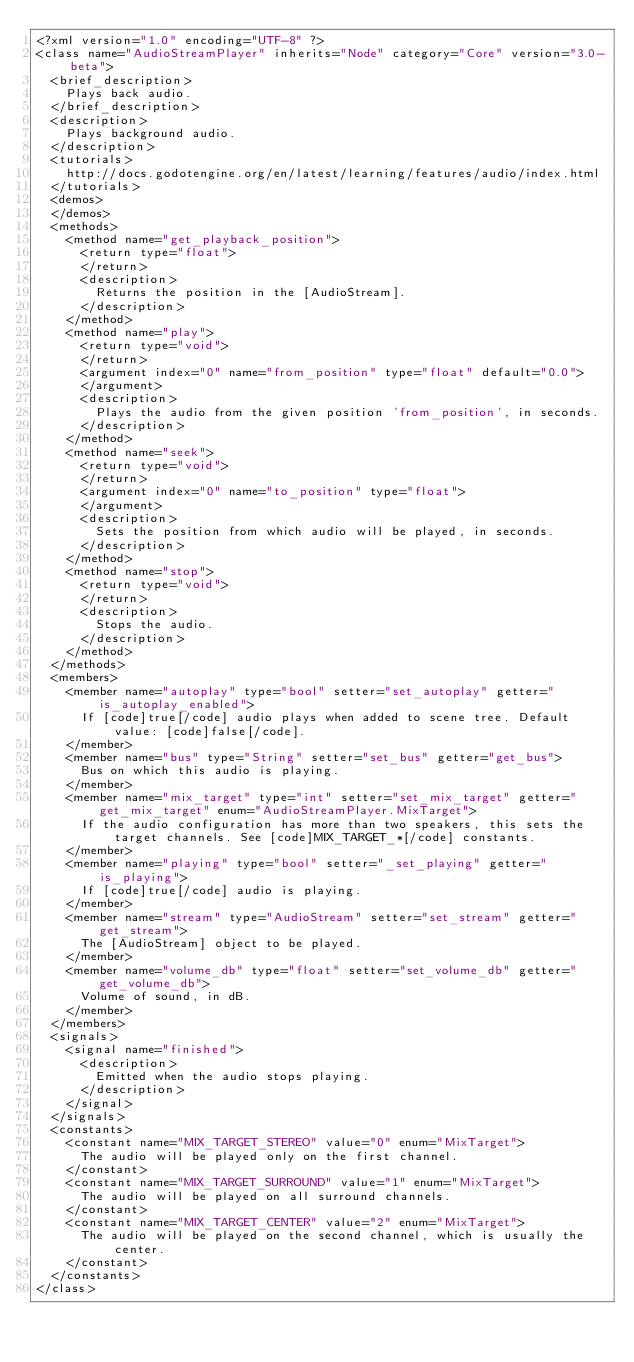Convert code to text. <code><loc_0><loc_0><loc_500><loc_500><_XML_><?xml version="1.0" encoding="UTF-8" ?>
<class name="AudioStreamPlayer" inherits="Node" category="Core" version="3.0-beta">
	<brief_description>
		Plays back audio.
	</brief_description>
	<description>
		Plays background audio.
	</description>
	<tutorials>
		http://docs.godotengine.org/en/latest/learning/features/audio/index.html
	</tutorials>
	<demos>
	</demos>
	<methods>
		<method name="get_playback_position">
			<return type="float">
			</return>
			<description>
				Returns the position in the [AudioStream].
			</description>
		</method>
		<method name="play">
			<return type="void">
			</return>
			<argument index="0" name="from_position" type="float" default="0.0">
			</argument>
			<description>
				Plays the audio from the given position 'from_position', in seconds.
			</description>
		</method>
		<method name="seek">
			<return type="void">
			</return>
			<argument index="0" name="to_position" type="float">
			</argument>
			<description>
				Sets the position from which audio will be played, in seconds.
			</description>
		</method>
		<method name="stop">
			<return type="void">
			</return>
			<description>
				Stops the audio.
			</description>
		</method>
	</methods>
	<members>
		<member name="autoplay" type="bool" setter="set_autoplay" getter="is_autoplay_enabled">
			If [code]true[/code] audio plays when added to scene tree. Default value: [code]false[/code].
		</member>
		<member name="bus" type="String" setter="set_bus" getter="get_bus">
			Bus on which this audio is playing.
		</member>
		<member name="mix_target" type="int" setter="set_mix_target" getter="get_mix_target" enum="AudioStreamPlayer.MixTarget">
			If the audio configuration has more than two speakers, this sets the target channels. See [code]MIX_TARGET_*[/code] constants.
		</member>
		<member name="playing" type="bool" setter="_set_playing" getter="is_playing">
			If [code]true[/code] audio is playing.
		</member>
		<member name="stream" type="AudioStream" setter="set_stream" getter="get_stream">
			The [AudioStream] object to be played.
		</member>
		<member name="volume_db" type="float" setter="set_volume_db" getter="get_volume_db">
			Volume of sound, in dB.
		</member>
	</members>
	<signals>
		<signal name="finished">
			<description>
				Emitted when the audio stops playing.
			</description>
		</signal>
	</signals>
	<constants>
		<constant name="MIX_TARGET_STEREO" value="0" enum="MixTarget">
			The audio will be played only on the first channel.
		</constant>
		<constant name="MIX_TARGET_SURROUND" value="1" enum="MixTarget">
			The audio will be played on all surround channels.
		</constant>
		<constant name="MIX_TARGET_CENTER" value="2" enum="MixTarget">
			The audio will be played on the second channel, which is usually the center.
		</constant>
	</constants>
</class>
</code> 